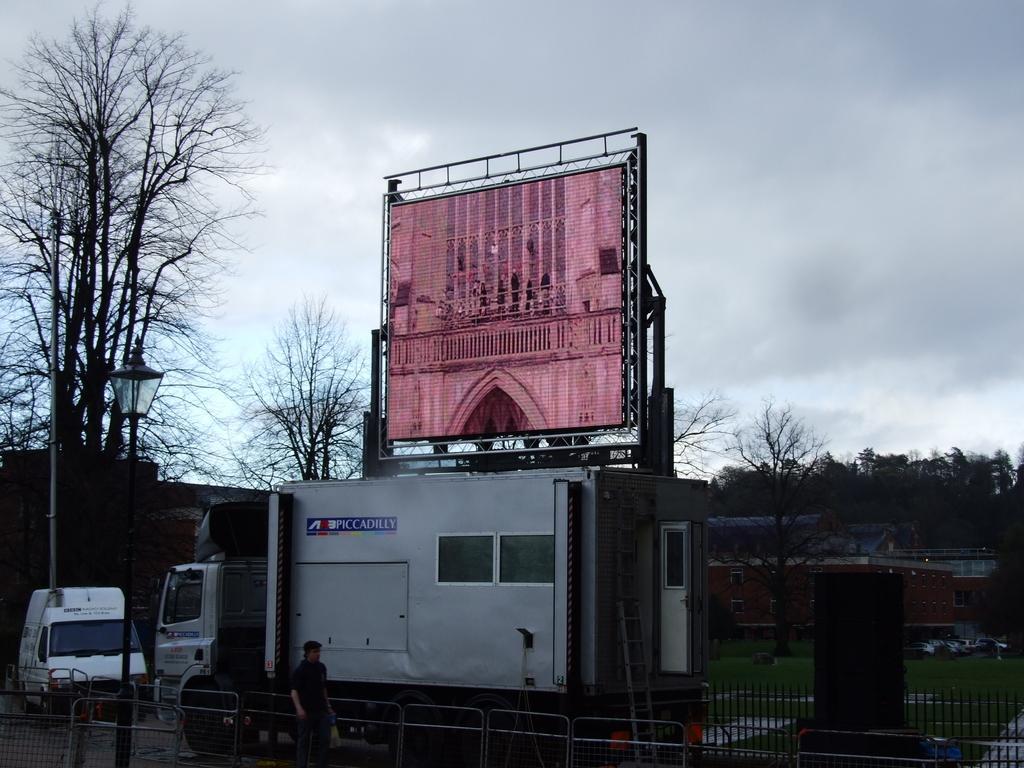Describe this image in one or two sentences. In this picture we can see a man holding a plastic cover with his hand and standing, vehicles on the road, fences, speaker, ladder, hoarding, trees, poles, lamp, buildings and in the background we can see the sky with clouds. 